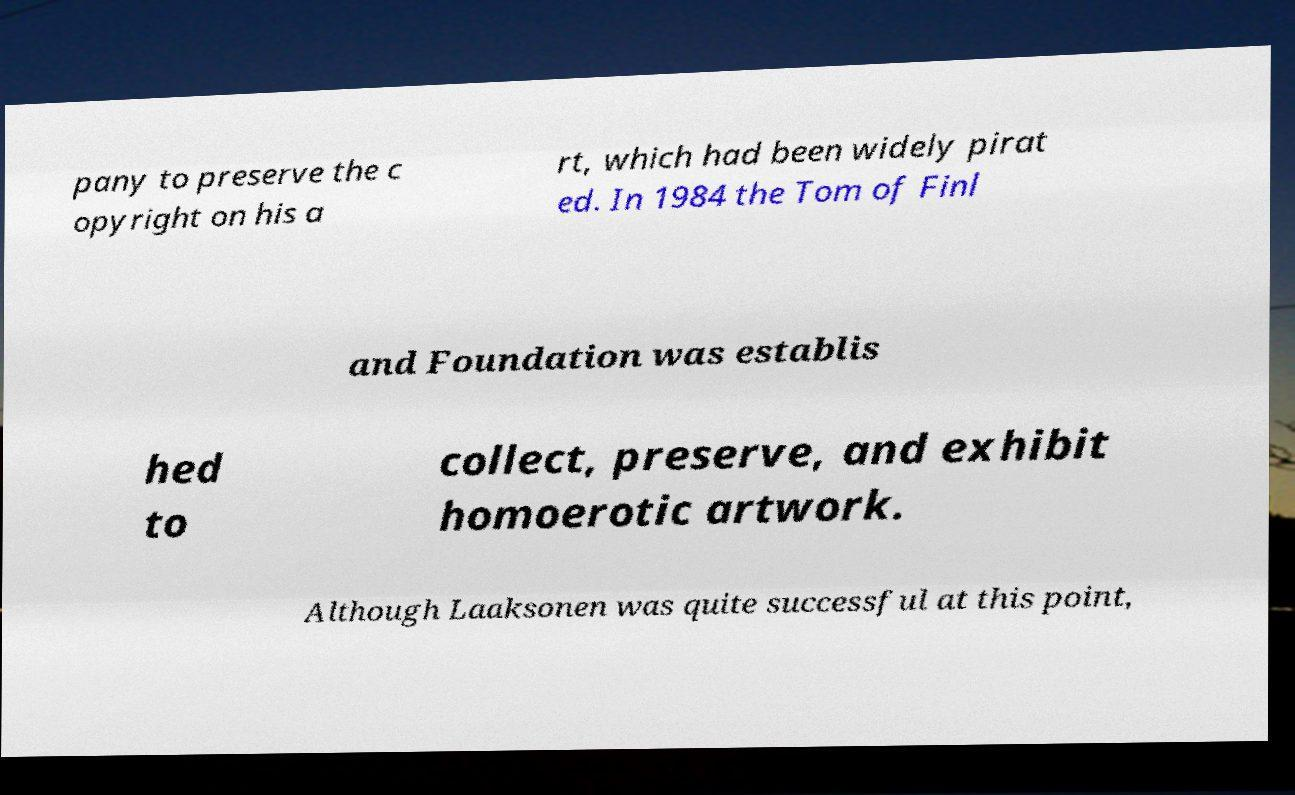For documentation purposes, I need the text within this image transcribed. Could you provide that? pany to preserve the c opyright on his a rt, which had been widely pirat ed. In 1984 the Tom of Finl and Foundation was establis hed to collect, preserve, and exhibit homoerotic artwork. Although Laaksonen was quite successful at this point, 